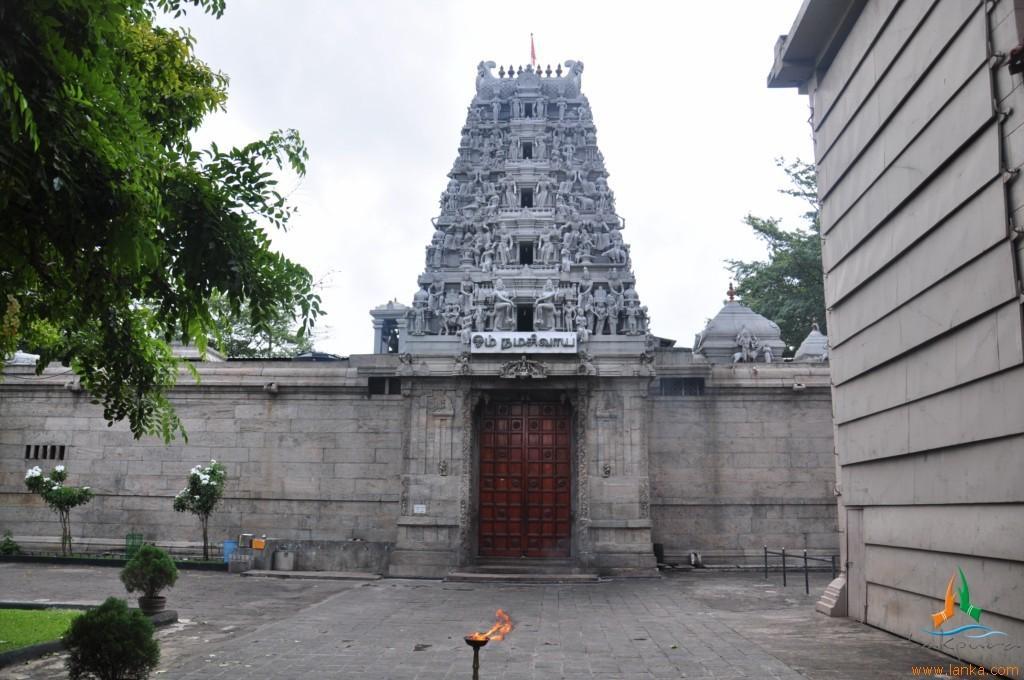In one or two sentences, can you explain what this image depicts? In the center of the image there is a temple and we can see a door. On the right there is a wall. On the left there are trees and plants. In the background there is sky. 